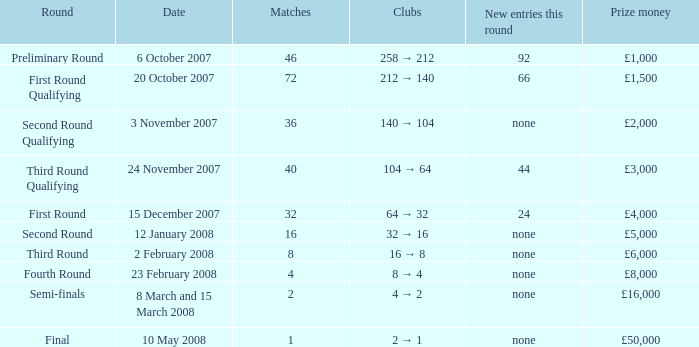What is the mean for games with a reward sum of £3,000? 40.0. 